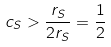Convert formula to latex. <formula><loc_0><loc_0><loc_500><loc_500>c _ { S } > \frac { r _ { S } } { 2 r _ { S } } = \frac { 1 } { 2 }</formula> 